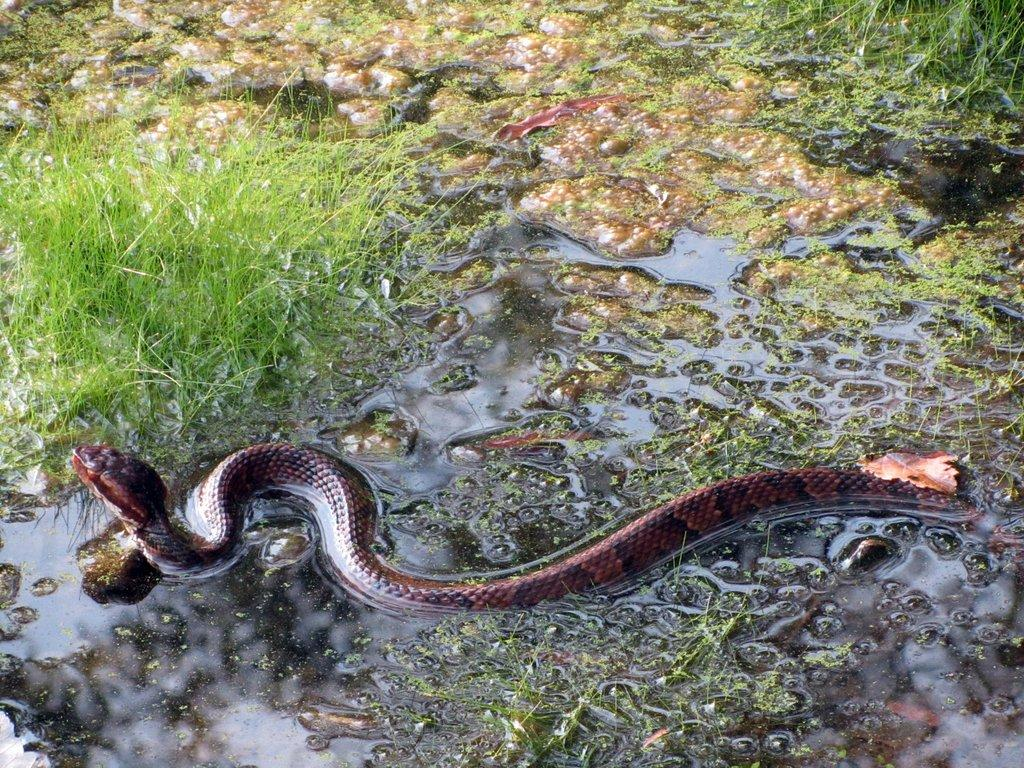What type of animal is in the image? There is a snake in the image. What color is the snake? The snake is maroon in color. What type of environment is depicted in the image? There is grass visible in the image, suggesting a natural setting. What is the liquid on the floor in the image? There is water on the floor in the image. How many hands can be seen holding the snake in the image? There are no hands visible in the image, as it only features a snake and the surrounding environment. 